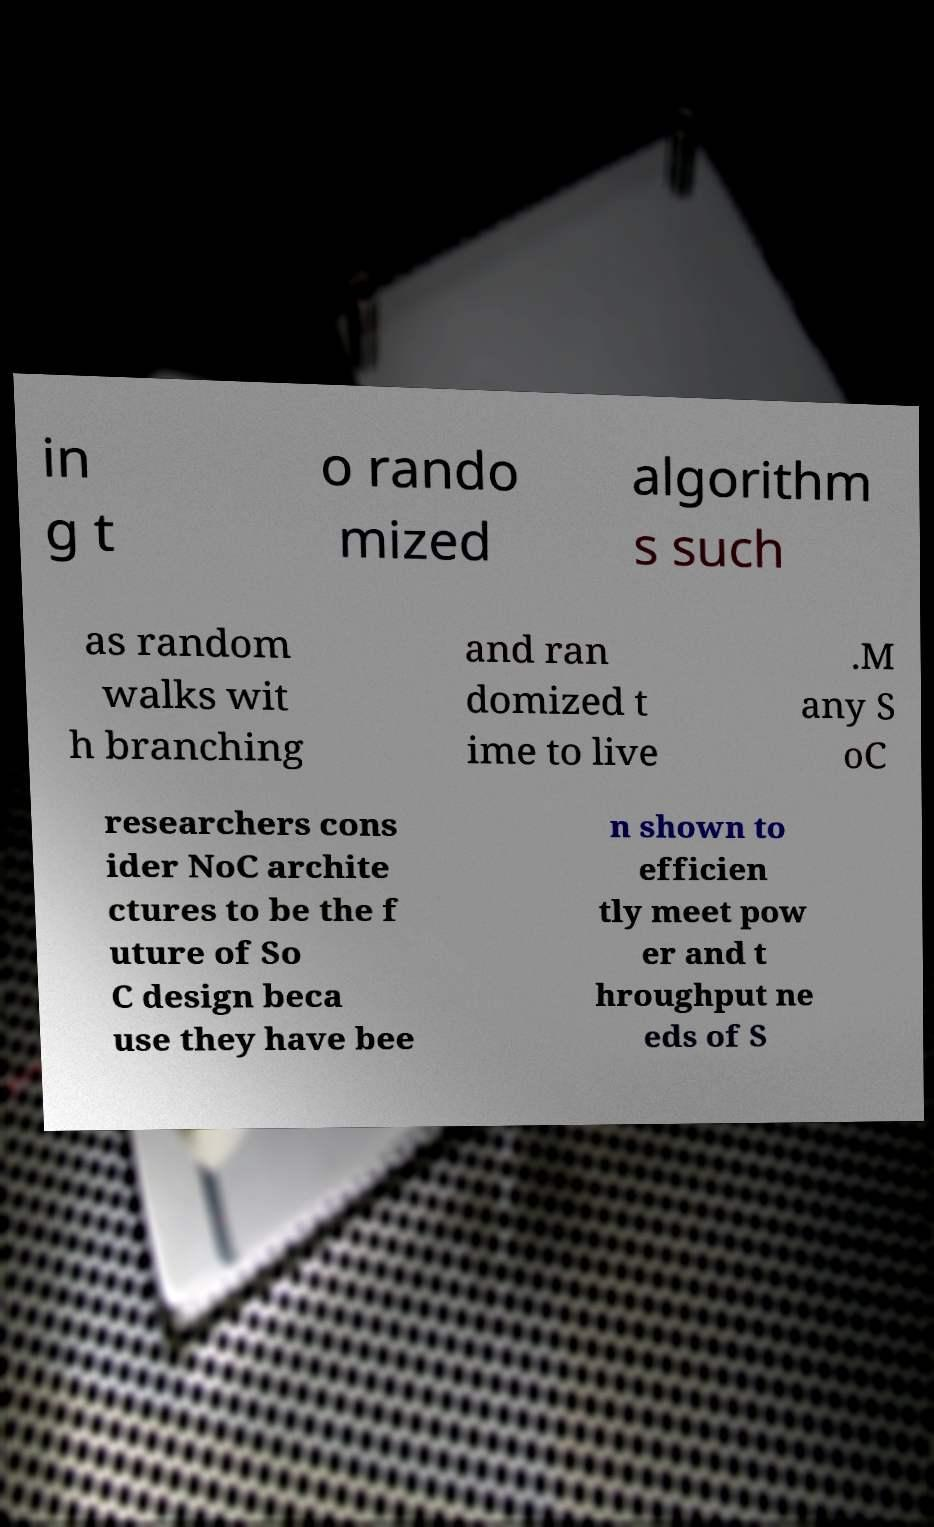Could you extract and type out the text from this image? in g t o rando mized algorithm s such as random walks wit h branching and ran domized t ime to live .M any S oC researchers cons ider NoC archite ctures to be the f uture of So C design beca use they have bee n shown to efficien tly meet pow er and t hroughput ne eds of S 